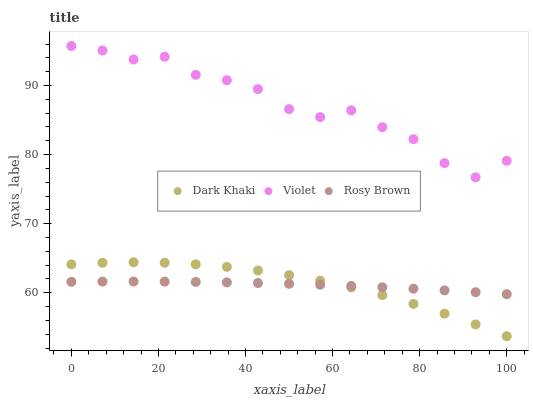Does Rosy Brown have the minimum area under the curve?
Answer yes or no. Yes. Does Violet have the maximum area under the curve?
Answer yes or no. Yes. Does Violet have the minimum area under the curve?
Answer yes or no. No. Does Rosy Brown have the maximum area under the curve?
Answer yes or no. No. Is Rosy Brown the smoothest?
Answer yes or no. Yes. Is Violet the roughest?
Answer yes or no. Yes. Is Violet the smoothest?
Answer yes or no. No. Is Rosy Brown the roughest?
Answer yes or no. No. Does Dark Khaki have the lowest value?
Answer yes or no. Yes. Does Rosy Brown have the lowest value?
Answer yes or no. No. Does Violet have the highest value?
Answer yes or no. Yes. Does Rosy Brown have the highest value?
Answer yes or no. No. Is Dark Khaki less than Violet?
Answer yes or no. Yes. Is Violet greater than Rosy Brown?
Answer yes or no. Yes. Does Rosy Brown intersect Dark Khaki?
Answer yes or no. Yes. Is Rosy Brown less than Dark Khaki?
Answer yes or no. No. Is Rosy Brown greater than Dark Khaki?
Answer yes or no. No. Does Dark Khaki intersect Violet?
Answer yes or no. No. 